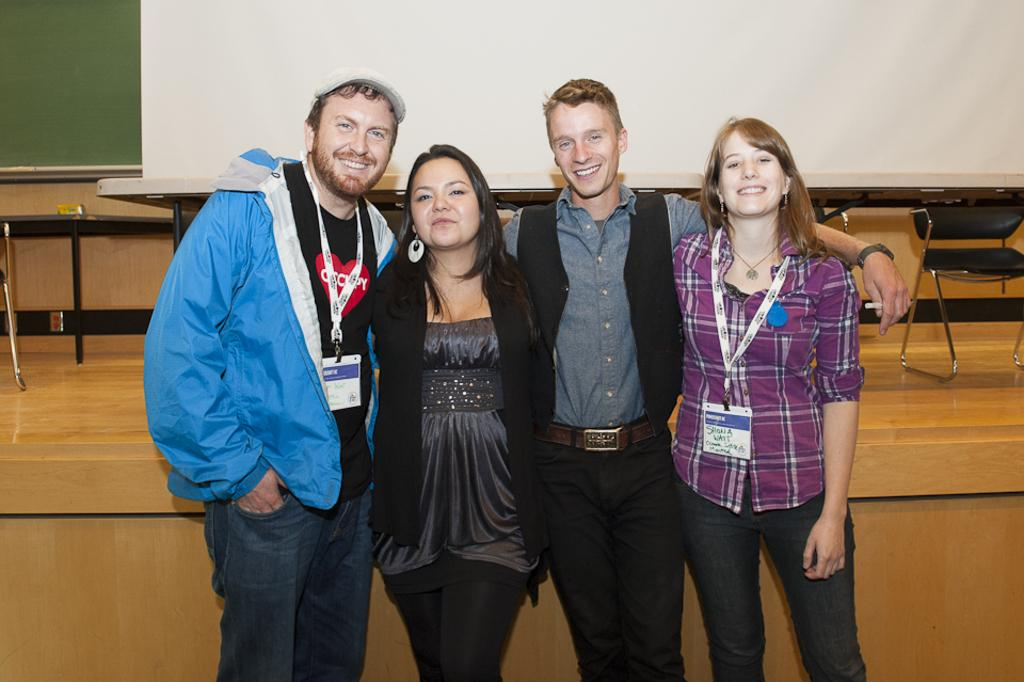How many people are in the image? There are four persons standing in the center of the image. What can be seen in the background of the image? There is a board, a wall, a table, and chairs in the background of the image. What type of list can be seen on the table in the image? There is no list present on the table in the image. What topic are the four persons discussing in the image? The image does not provide any information about the conversation or topic being discussed by the four persons. 